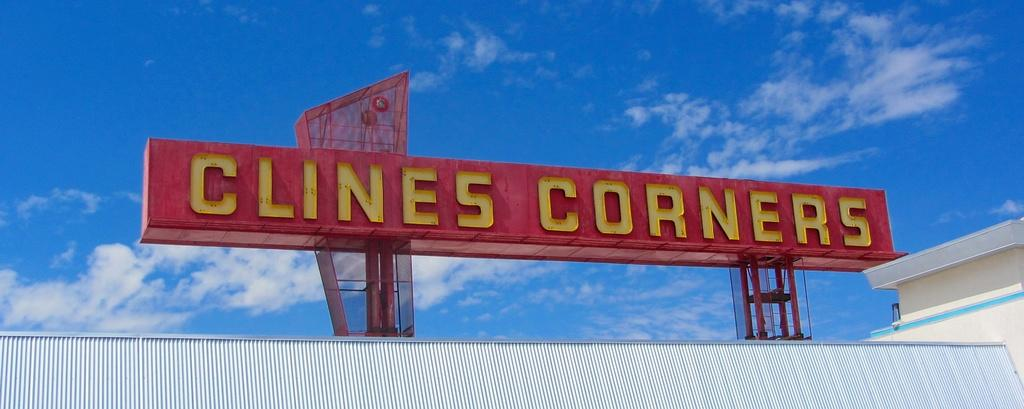<image>
Create a compact narrative representing the image presented. Clines Corners is being advertised on a Red signboard with yellow letters. 